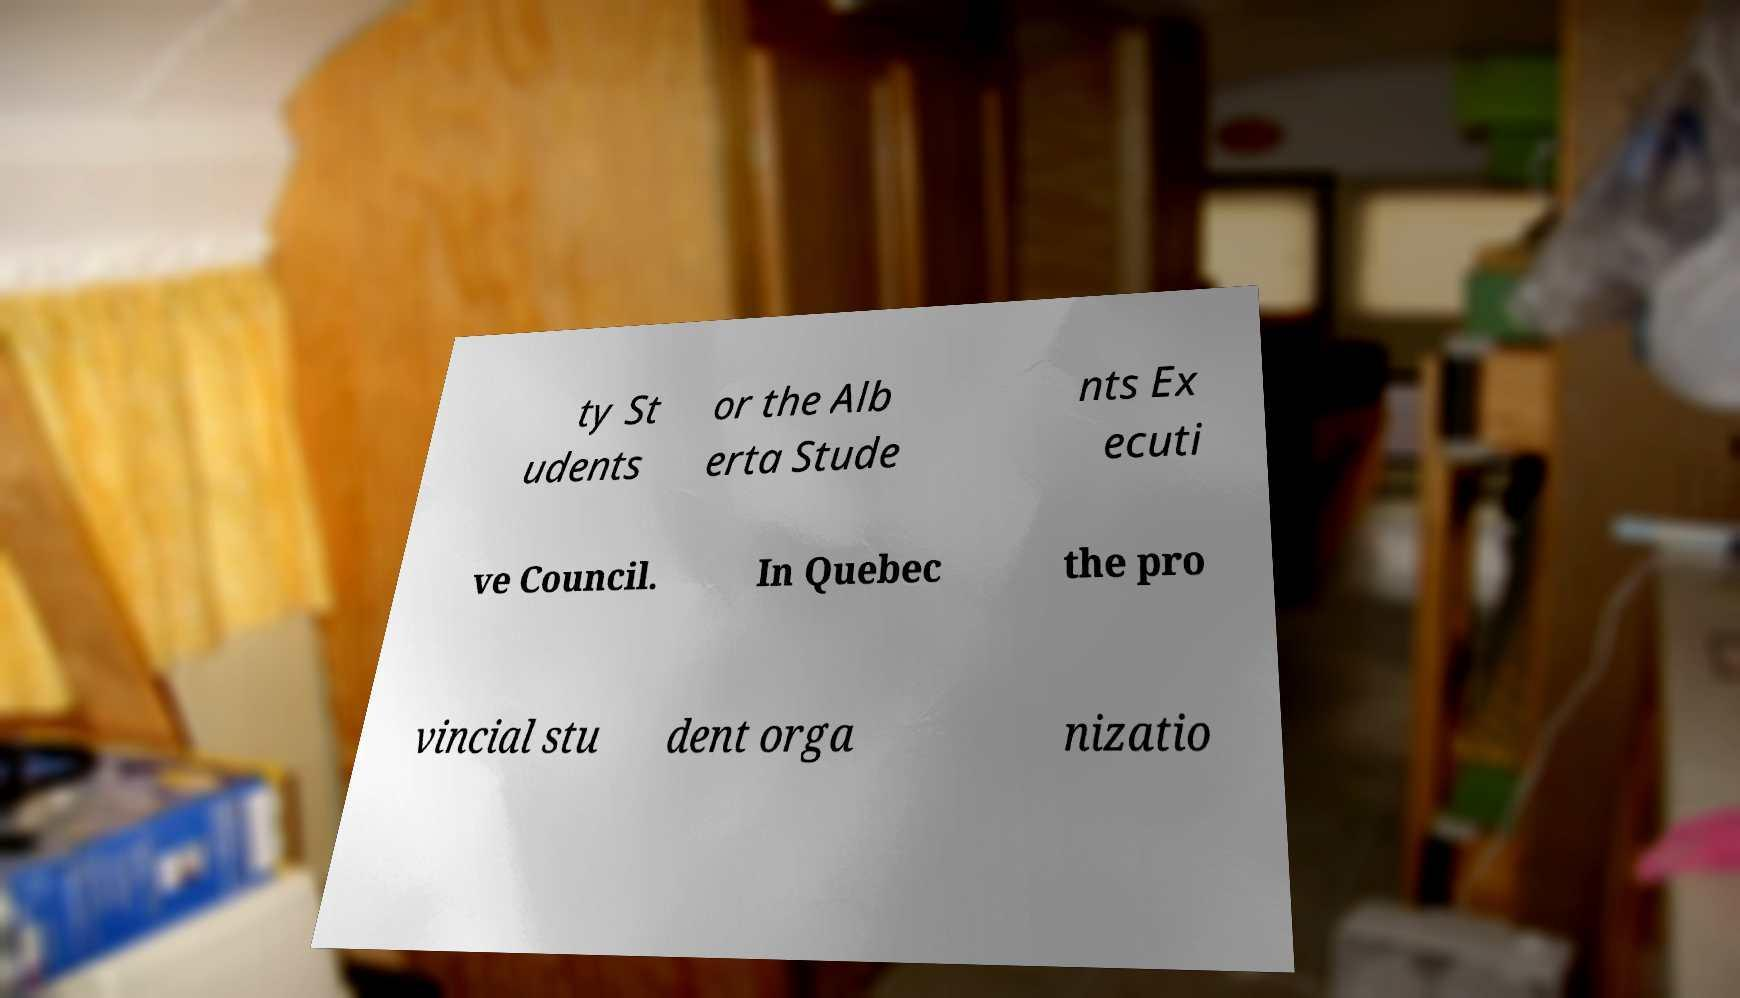Please identify and transcribe the text found in this image. ty St udents or the Alb erta Stude nts Ex ecuti ve Council. In Quebec the pro vincial stu dent orga nizatio 